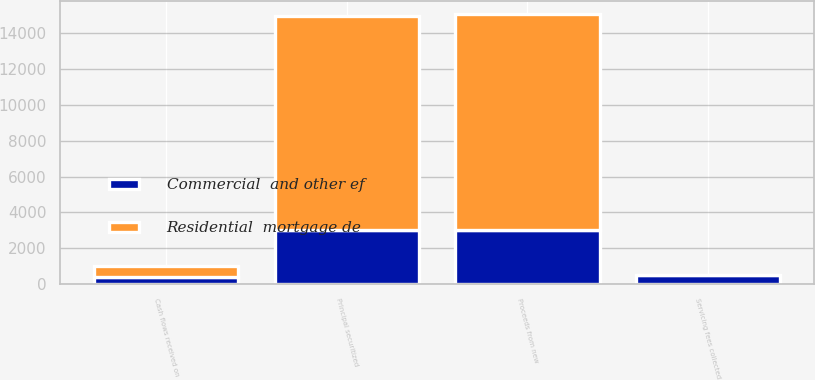Convert chart. <chart><loc_0><loc_0><loc_500><loc_500><stacked_bar_chart><ecel><fcel>Principal securitized<fcel>Proceeds from new<fcel>Servicing fees collected<fcel>Cash flows received on<nl><fcel>Commercial  and other ef<fcel>3008<fcel>3022<fcel>528<fcel>407<nl><fcel>Residential  mortgage de<fcel>11933<fcel>12011<fcel>3<fcel>597<nl></chart> 